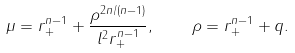<formula> <loc_0><loc_0><loc_500><loc_500>\mu = r _ { + } ^ { n - 1 } + \frac { \rho ^ { 2 n / ( n - 1 ) } } { l ^ { 2 } r _ { + } ^ { n - 1 } } , \quad \rho = r _ { + } ^ { n - 1 } + q .</formula> 